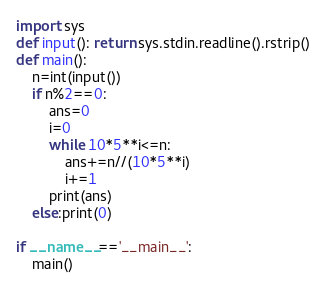<code> <loc_0><loc_0><loc_500><loc_500><_Python_>import sys
def input(): return sys.stdin.readline().rstrip()
def main():
    n=int(input())
    if n%2==0:
        ans=0
        i=0
        while 10*5**i<=n:
            ans+=n//(10*5**i)
            i+=1
        print(ans)
    else:print(0)

if __name__=='__main__':
    main()</code> 